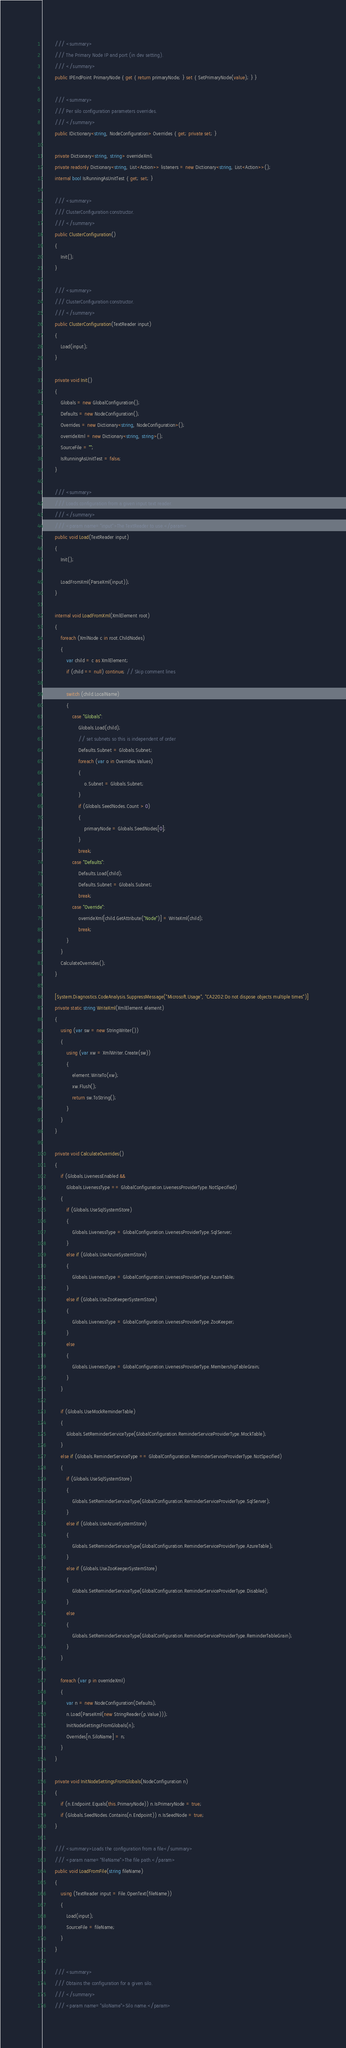Convert code to text. <code><loc_0><loc_0><loc_500><loc_500><_C#_>        /// <summary>
        /// The Primary Node IP and port (in dev setting).
        /// </summary>
        public IPEndPoint PrimaryNode { get { return primaryNode; } set { SetPrimaryNode(value); } }

        /// <summary>
        /// Per silo configuration parameters overrides.
        /// </summary>
        public IDictionary<string, NodeConfiguration> Overrides { get; private set; }

        private Dictionary<string, string> overrideXml;
        private readonly Dictionary<string, List<Action>> listeners = new Dictionary<string, List<Action>>();
        internal bool IsRunningAsUnitTest { get; set; }

        /// <summary>
        /// ClusterConfiguration constructor.
        /// </summary>
        public ClusterConfiguration()
        {
            Init();
        }

        /// <summary>
        /// ClusterConfiguration constructor.
        /// </summary>
        public ClusterConfiguration(TextReader input)
        {
            Load(input);
        }

        private void Init()
        {
            Globals = new GlobalConfiguration();
            Defaults = new NodeConfiguration();
            Overrides = new Dictionary<string, NodeConfiguration>();
            overrideXml = new Dictionary<string, string>();
            SourceFile = "";
            IsRunningAsUnitTest = false;
        }

        /// <summary>
        /// Loads configuration from a given input text reader.
        /// </summary>
        /// <param name="input">The TextReader to use.</param>
        public void Load(TextReader input)
        {
            Init();

            LoadFromXml(ParseXml(input));
        }

        internal void LoadFromXml(XmlElement root)
        {
            foreach (XmlNode c in root.ChildNodes)
            {
                var child = c as XmlElement;
                if (child == null) continue; // Skip comment lines

                switch (child.LocalName)
                {
                    case "Globals":
                        Globals.Load(child);
                        // set subnets so this is independent of order
                        Defaults.Subnet = Globals.Subnet;
                        foreach (var o in Overrides.Values)
                        {
                            o.Subnet = Globals.Subnet;
                        }
                        if (Globals.SeedNodes.Count > 0)
                        {
                            primaryNode = Globals.SeedNodes[0];
                        }
                        break;
                    case "Defaults":
                        Defaults.Load(child);
                        Defaults.Subnet = Globals.Subnet;
                        break;
                    case "Override":
                        overrideXml[child.GetAttribute("Node")] = WriteXml(child);
                        break;
                }
            }
            CalculateOverrides();
        }

        [System.Diagnostics.CodeAnalysis.SuppressMessage("Microsoft.Usage", "CA2202:Do not dispose objects multiple times")]
        private static string WriteXml(XmlElement element)
        {
            using (var sw = new StringWriter())
            {
                using (var xw = XmlWriter.Create(sw))
                {
                    element.WriteTo(xw);
                    xw.Flush();
                    return sw.ToString();
                }
            }
        }

        private void CalculateOverrides()
        {
            if (Globals.LivenessEnabled &&
                Globals.LivenessType == GlobalConfiguration.LivenessProviderType.NotSpecified)
            {
                if (Globals.UseSqlSystemStore)
                {
                    Globals.LivenessType = GlobalConfiguration.LivenessProviderType.SqlServer;
                }
                else if (Globals.UseAzureSystemStore)
                {
                    Globals.LivenessType = GlobalConfiguration.LivenessProviderType.AzureTable;
                }
                else if (Globals.UseZooKeeperSystemStore)
                {
                    Globals.LivenessType = GlobalConfiguration.LivenessProviderType.ZooKeeper;
                }
                else
                {
                    Globals.LivenessType = GlobalConfiguration.LivenessProviderType.MembershipTableGrain;
                }
            }

            if (Globals.UseMockReminderTable)
            {
                Globals.SetReminderServiceType(GlobalConfiguration.ReminderServiceProviderType.MockTable);
            }
            else if (Globals.ReminderServiceType == GlobalConfiguration.ReminderServiceProviderType.NotSpecified)
            {
                if (Globals.UseSqlSystemStore)
                {
                    Globals.SetReminderServiceType(GlobalConfiguration.ReminderServiceProviderType.SqlServer);
                }
                else if (Globals.UseAzureSystemStore)
                {
                    Globals.SetReminderServiceType(GlobalConfiguration.ReminderServiceProviderType.AzureTable);
                }
                else if (Globals.UseZooKeeperSystemStore)
                {
                    Globals.SetReminderServiceType(GlobalConfiguration.ReminderServiceProviderType.Disabled);
                }
                else
                {
                    Globals.SetReminderServiceType(GlobalConfiguration.ReminderServiceProviderType.ReminderTableGrain);
                }
            }

            foreach (var p in overrideXml)
            {
                var n = new NodeConfiguration(Defaults);
                n.Load(ParseXml(new StringReader(p.Value)));
                InitNodeSettingsFromGlobals(n);
                Overrides[n.SiloName] = n;
            }
        }

        private void InitNodeSettingsFromGlobals(NodeConfiguration n)
        {
            if (n.Endpoint.Equals(this.PrimaryNode)) n.IsPrimaryNode = true;
            if (Globals.SeedNodes.Contains(n.Endpoint)) n.IsSeedNode = true;
        }

        /// <summary>Loads the configuration from a file</summary>
        /// <param name="fileName">The file path.</param>
        public void LoadFromFile(string fileName)
        {
            using (TextReader input = File.OpenText(fileName))
            {
                Load(input);
                SourceFile = fileName;
            }
        }

        /// <summary>
        /// Obtains the configuration for a given silo.
        /// </summary>
        /// <param name="siloName">Silo name.</param></code> 